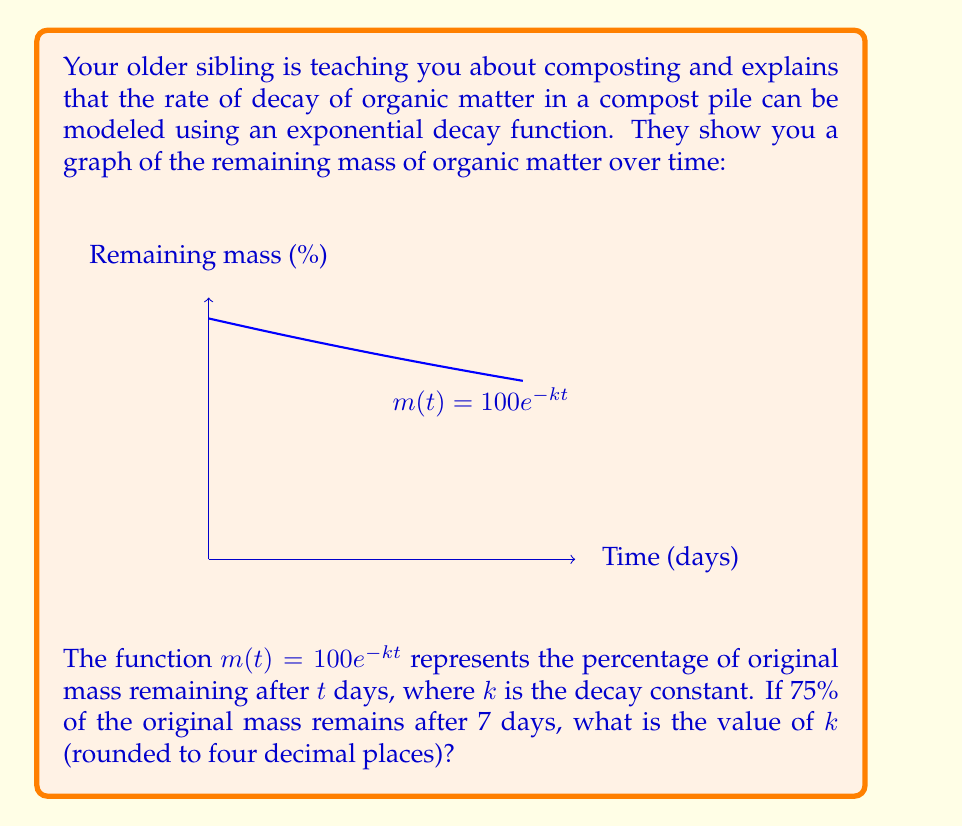Solve this math problem. Let's approach this step-by-step:

1) We're given that $m(t) = 100e^{-kt}$ represents the percentage of original mass remaining after $t$ days.

2) We know that after 7 days, 75% of the mass remains. We can express this mathematically as:

   $m(7) = 75$

3) Let's substitute this into our equation:

   $75 = 100e^{-k(7)}$

4) Now, let's solve for $k$:

   $\frac{75}{100} = e^{-7k}$

5) Take the natural logarithm of both sides:

   $\ln(\frac{75}{100}) = \ln(e^{-7k})$

6) Simplify the right side using the properties of logarithms:

   $\ln(0.75) = -7k$

7) Solve for $k$:

   $k = -\frac{\ln(0.75)}{7}$

8) Calculate this value:

   $k \approx 0.0411$

9) Rounding to four decimal places:

   $k \approx 0.0411$

Therefore, the decay constant $k$ is approximately 0.0411.
Answer: $k \approx 0.0411$ 